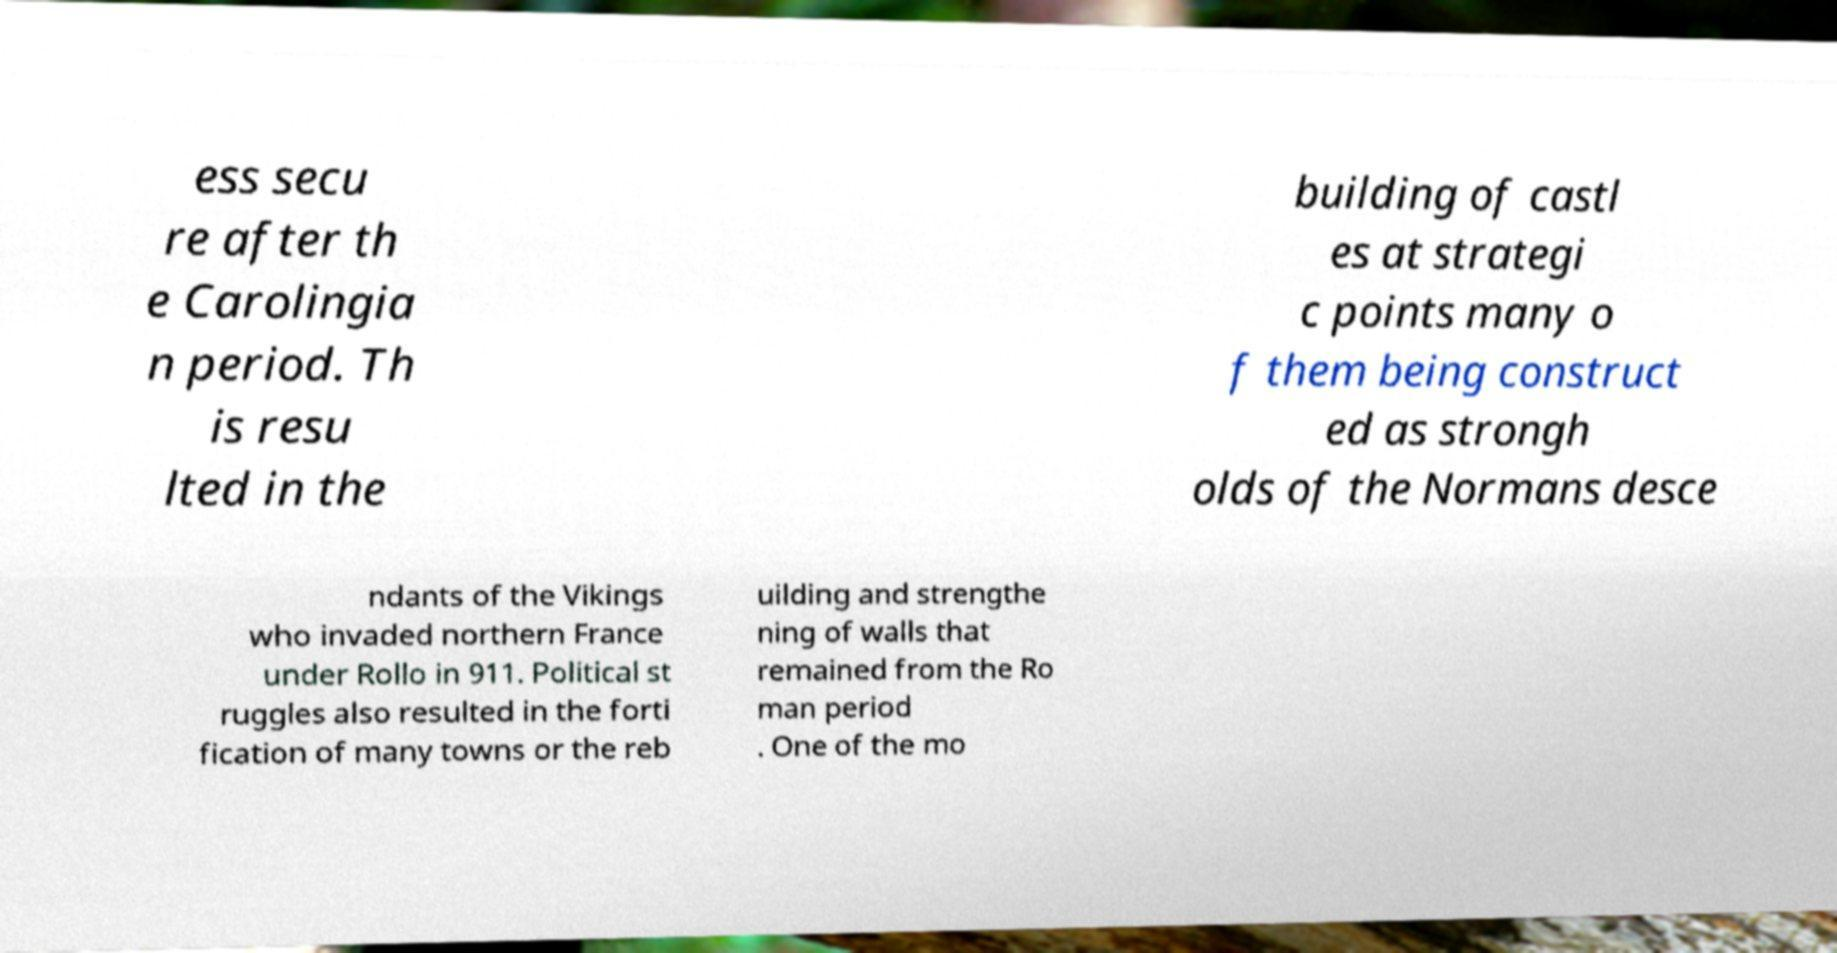Could you extract and type out the text from this image? ess secu re after th e Carolingia n period. Th is resu lted in the building of castl es at strategi c points many o f them being construct ed as strongh olds of the Normans desce ndants of the Vikings who invaded northern France under Rollo in 911. Political st ruggles also resulted in the forti fication of many towns or the reb uilding and strengthe ning of walls that remained from the Ro man period . One of the mo 